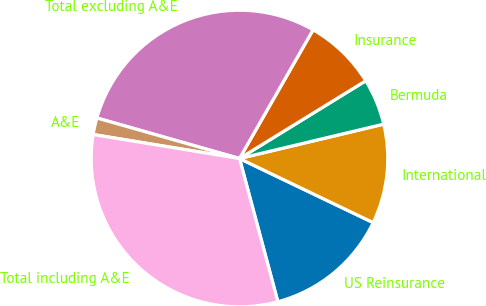<chart> <loc_0><loc_0><loc_500><loc_500><pie_chart><fcel>US Reinsurance<fcel>International<fcel>Bermuda<fcel>Insurance<fcel>Total excluding A&E<fcel>A&E<fcel>Total including A&E<nl><fcel>13.72%<fcel>10.84%<fcel>5.06%<fcel>7.95%<fcel>28.86%<fcel>1.82%<fcel>31.75%<nl></chart> 